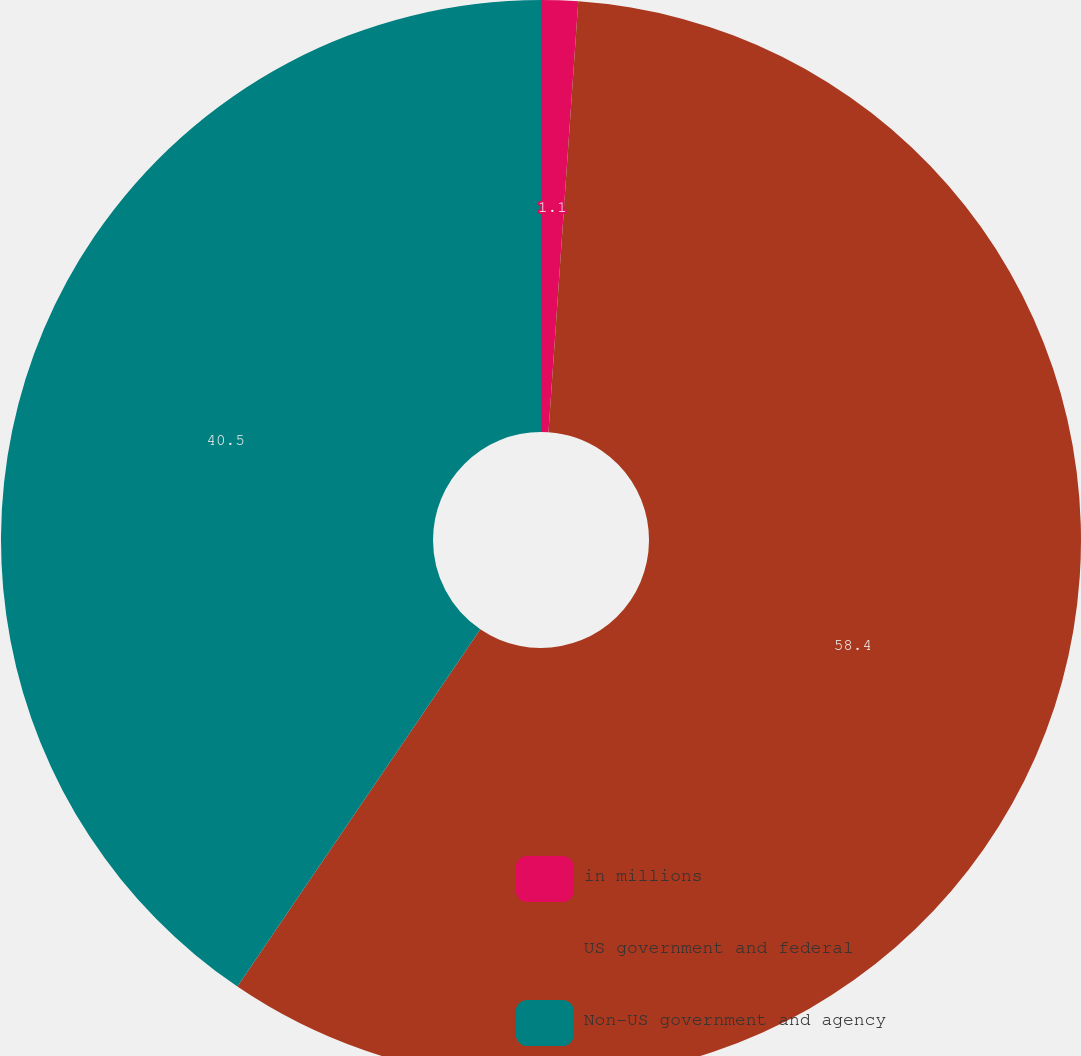Convert chart to OTSL. <chart><loc_0><loc_0><loc_500><loc_500><pie_chart><fcel>in millions<fcel>US government and federal<fcel>Non-US government and agency<nl><fcel>1.1%<fcel>58.41%<fcel>40.5%<nl></chart> 